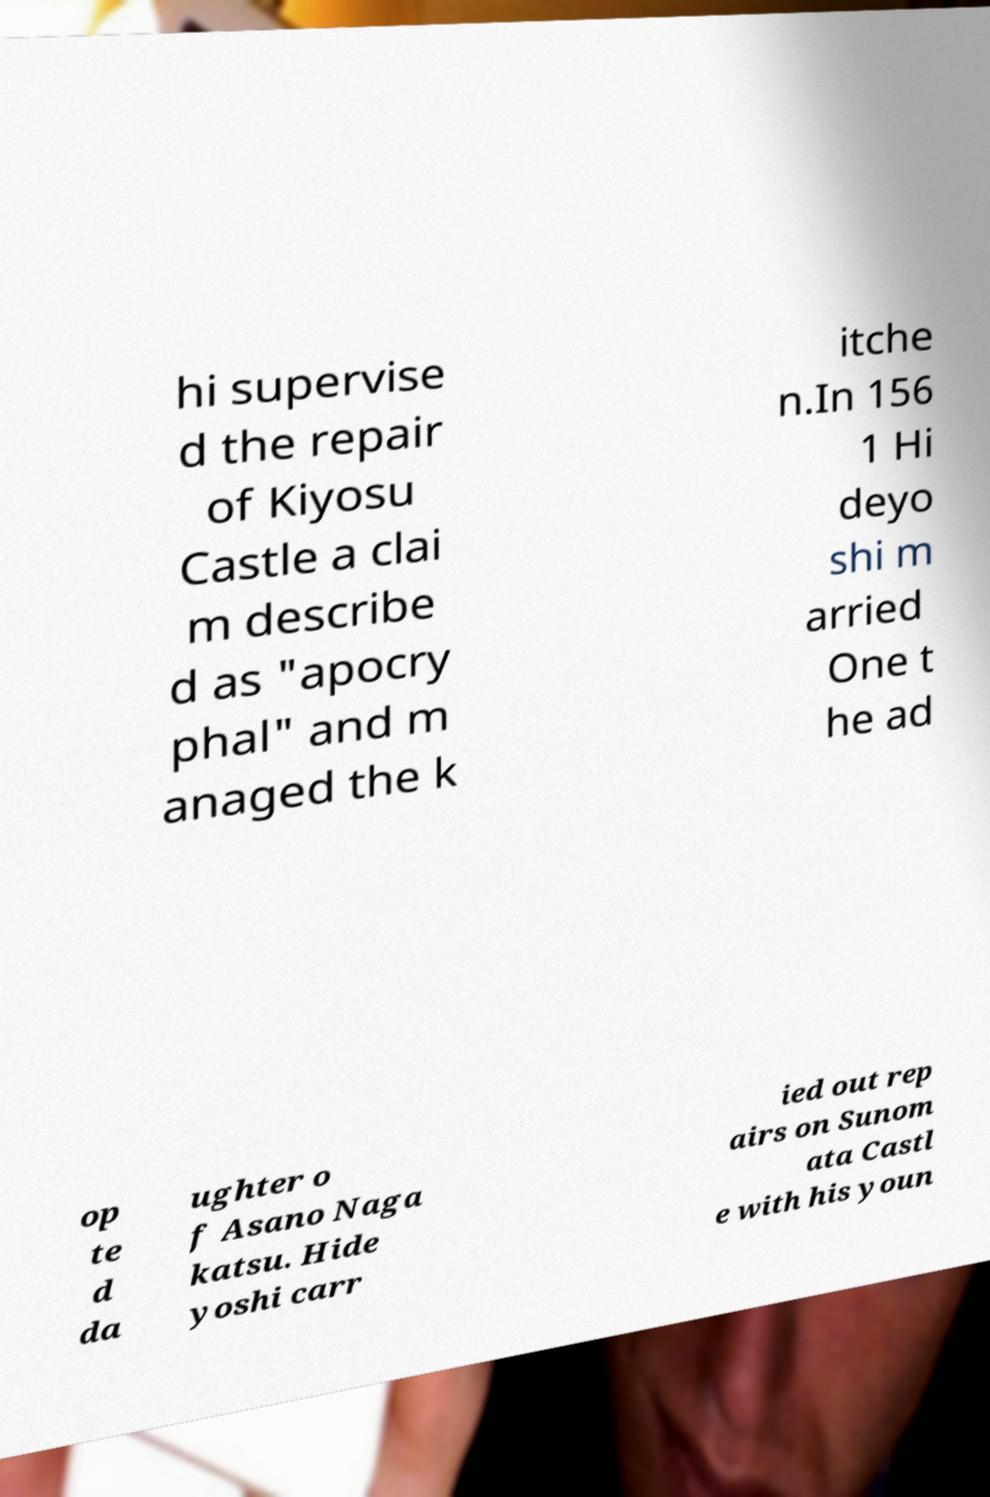Can you read and provide the text displayed in the image?This photo seems to have some interesting text. Can you extract and type it out for me? hi supervise d the repair of Kiyosu Castle a clai m describe d as "apocry phal" and m anaged the k itche n.In 156 1 Hi deyo shi m arried One t he ad op te d da ughter o f Asano Naga katsu. Hide yoshi carr ied out rep airs on Sunom ata Castl e with his youn 